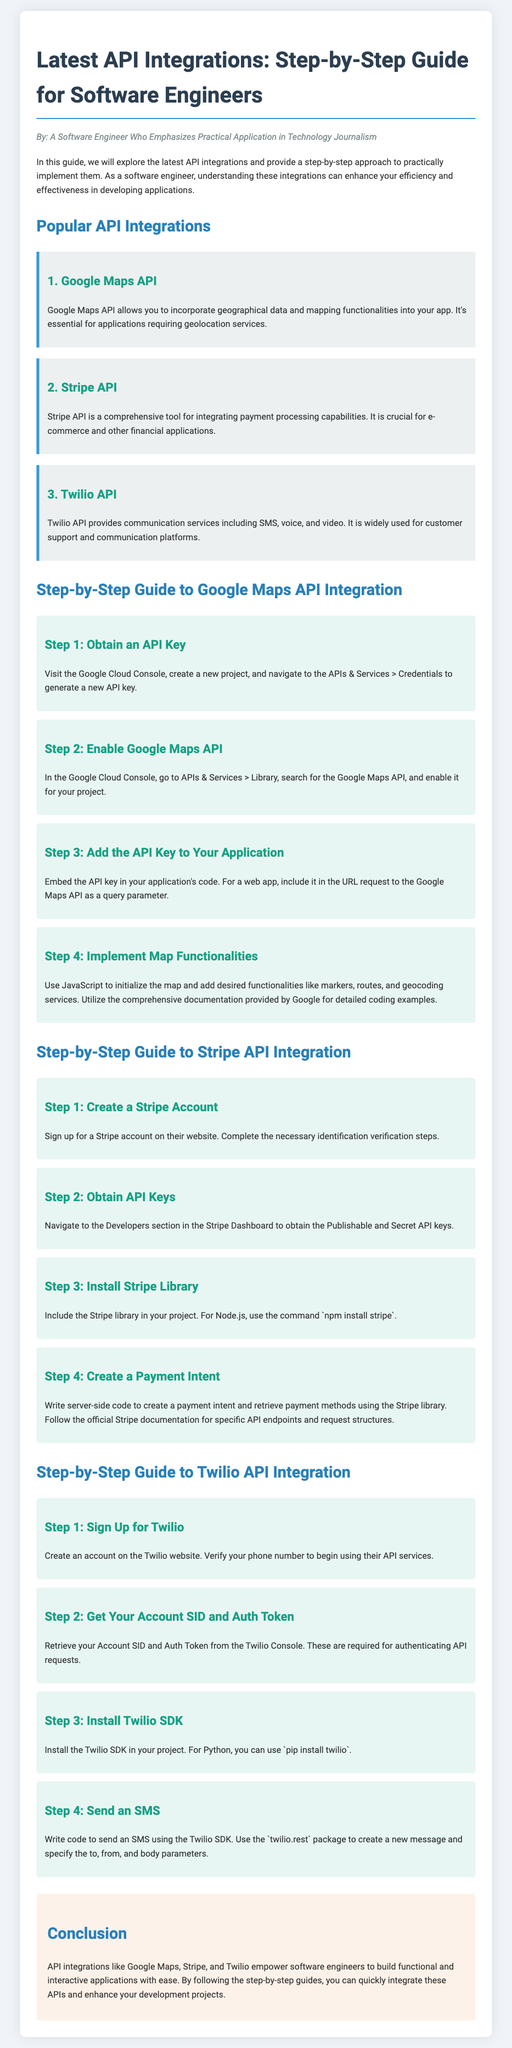What is the title of the document? The title is stated at the beginning of the document and is "Latest API Integrations: Step-by-Step Guide".
Answer: Latest API Integrations: Step-by-Step Guide Who is the author of the guide? The author is mentioned in the introductory paragraph as "A Software Engineer Who Emphasizes Practical Application in Technology Journalism".
Answer: A Software Engineer Who Emphasizes Practical Application in Technology Journalism What is the first API integration mentioned? The first API integration is listed under the popular integrations section, which is "Google Maps API".
Answer: Google Maps API How many steps are there for the Google Maps API integration? The steps for Google Maps API integration are listed, and there are four steps provided.
Answer: 4 What is the command to install the Stripe library? The document specifies the command to install the Stripe library for Node.js, which is given as "npm install stripe".
Answer: npm install stripe Which API is used for payment processing? The document mentions the "Stripe API" as the one for integrating payment processing capabilities.
Answer: Stripe API What do you need to verify to sign up for Twilio? The document states that you need to verify your phone number to begin using Twilio's API services.
Answer: Phone number What is the final section of the document titled? The conclusion wraps up the guide and is titled "Conclusion".
Answer: Conclusion What is the purpose of API integrations according to the document? The document states that API integrations empower software engineers to build functional and interactive applications with ease.
Answer: Build functional and interactive applications 